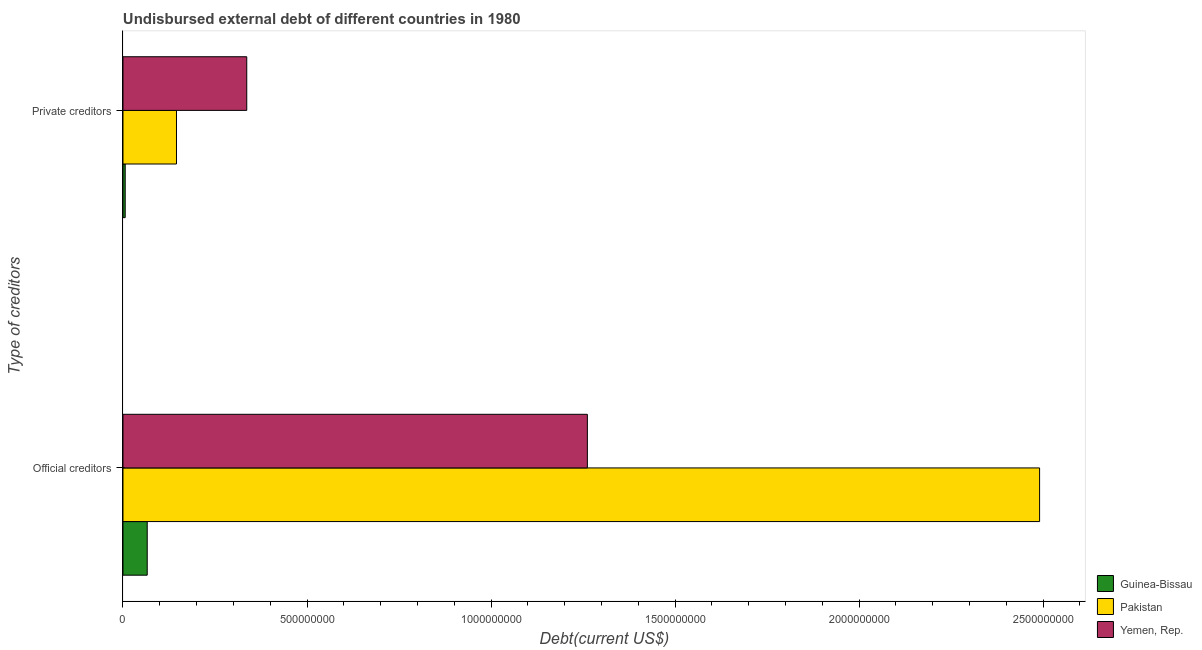How many groups of bars are there?
Provide a short and direct response. 2. Are the number of bars per tick equal to the number of legend labels?
Offer a very short reply. Yes. How many bars are there on the 1st tick from the bottom?
Provide a succinct answer. 3. What is the label of the 2nd group of bars from the top?
Your answer should be compact. Official creditors. What is the undisbursed external debt of private creditors in Yemen, Rep.?
Give a very brief answer. 3.36e+08. Across all countries, what is the maximum undisbursed external debt of private creditors?
Ensure brevity in your answer.  3.36e+08. Across all countries, what is the minimum undisbursed external debt of private creditors?
Your answer should be compact. 6.04e+06. In which country was the undisbursed external debt of private creditors maximum?
Make the answer very short. Yemen, Rep. In which country was the undisbursed external debt of official creditors minimum?
Your answer should be compact. Guinea-Bissau. What is the total undisbursed external debt of private creditors in the graph?
Offer a terse response. 4.88e+08. What is the difference between the undisbursed external debt of official creditors in Guinea-Bissau and that in Yemen, Rep.?
Keep it short and to the point. -1.20e+09. What is the difference between the undisbursed external debt of private creditors in Guinea-Bissau and the undisbursed external debt of official creditors in Pakistan?
Provide a short and direct response. -2.48e+09. What is the average undisbursed external debt of official creditors per country?
Ensure brevity in your answer.  1.27e+09. What is the difference between the undisbursed external debt of official creditors and undisbursed external debt of private creditors in Yemen, Rep.?
Your answer should be very brief. 9.25e+08. In how many countries, is the undisbursed external debt of private creditors greater than 200000000 US$?
Make the answer very short. 1. What is the ratio of the undisbursed external debt of official creditors in Guinea-Bissau to that in Pakistan?
Your response must be concise. 0.03. What does the 1st bar from the bottom in Private creditors represents?
Your response must be concise. Guinea-Bissau. How many bars are there?
Offer a very short reply. 6. Are all the bars in the graph horizontal?
Your answer should be compact. Yes. How many legend labels are there?
Provide a short and direct response. 3. How are the legend labels stacked?
Your answer should be very brief. Vertical. What is the title of the graph?
Offer a very short reply. Undisbursed external debt of different countries in 1980. What is the label or title of the X-axis?
Give a very brief answer. Debt(current US$). What is the label or title of the Y-axis?
Provide a succinct answer. Type of creditors. What is the Debt(current US$) in Guinea-Bissau in Official creditors?
Ensure brevity in your answer.  6.59e+07. What is the Debt(current US$) in Pakistan in Official creditors?
Your answer should be very brief. 2.49e+09. What is the Debt(current US$) in Yemen, Rep. in Official creditors?
Make the answer very short. 1.26e+09. What is the Debt(current US$) in Guinea-Bissau in Private creditors?
Your answer should be compact. 6.04e+06. What is the Debt(current US$) of Pakistan in Private creditors?
Provide a succinct answer. 1.45e+08. What is the Debt(current US$) of Yemen, Rep. in Private creditors?
Provide a short and direct response. 3.36e+08. Across all Type of creditors, what is the maximum Debt(current US$) in Guinea-Bissau?
Your answer should be very brief. 6.59e+07. Across all Type of creditors, what is the maximum Debt(current US$) in Pakistan?
Your answer should be very brief. 2.49e+09. Across all Type of creditors, what is the maximum Debt(current US$) in Yemen, Rep.?
Your answer should be compact. 1.26e+09. Across all Type of creditors, what is the minimum Debt(current US$) of Guinea-Bissau?
Offer a very short reply. 6.04e+06. Across all Type of creditors, what is the minimum Debt(current US$) in Pakistan?
Your response must be concise. 1.45e+08. Across all Type of creditors, what is the minimum Debt(current US$) of Yemen, Rep.?
Ensure brevity in your answer.  3.36e+08. What is the total Debt(current US$) in Guinea-Bissau in the graph?
Offer a terse response. 7.19e+07. What is the total Debt(current US$) in Pakistan in the graph?
Ensure brevity in your answer.  2.64e+09. What is the total Debt(current US$) in Yemen, Rep. in the graph?
Keep it short and to the point. 1.60e+09. What is the difference between the Debt(current US$) in Guinea-Bissau in Official creditors and that in Private creditors?
Your answer should be very brief. 5.98e+07. What is the difference between the Debt(current US$) in Pakistan in Official creditors and that in Private creditors?
Your response must be concise. 2.35e+09. What is the difference between the Debt(current US$) in Yemen, Rep. in Official creditors and that in Private creditors?
Provide a succinct answer. 9.25e+08. What is the difference between the Debt(current US$) in Guinea-Bissau in Official creditors and the Debt(current US$) in Pakistan in Private creditors?
Offer a very short reply. -7.95e+07. What is the difference between the Debt(current US$) of Guinea-Bissau in Official creditors and the Debt(current US$) of Yemen, Rep. in Private creditors?
Make the answer very short. -2.70e+08. What is the difference between the Debt(current US$) of Pakistan in Official creditors and the Debt(current US$) of Yemen, Rep. in Private creditors?
Offer a very short reply. 2.15e+09. What is the average Debt(current US$) of Guinea-Bissau per Type of creditors?
Offer a very short reply. 3.60e+07. What is the average Debt(current US$) of Pakistan per Type of creditors?
Provide a succinct answer. 1.32e+09. What is the average Debt(current US$) in Yemen, Rep. per Type of creditors?
Ensure brevity in your answer.  7.99e+08. What is the difference between the Debt(current US$) of Guinea-Bissau and Debt(current US$) of Pakistan in Official creditors?
Provide a succinct answer. -2.42e+09. What is the difference between the Debt(current US$) of Guinea-Bissau and Debt(current US$) of Yemen, Rep. in Official creditors?
Keep it short and to the point. -1.20e+09. What is the difference between the Debt(current US$) of Pakistan and Debt(current US$) of Yemen, Rep. in Official creditors?
Provide a short and direct response. 1.23e+09. What is the difference between the Debt(current US$) in Guinea-Bissau and Debt(current US$) in Pakistan in Private creditors?
Provide a short and direct response. -1.39e+08. What is the difference between the Debt(current US$) in Guinea-Bissau and Debt(current US$) in Yemen, Rep. in Private creditors?
Your answer should be very brief. -3.30e+08. What is the difference between the Debt(current US$) in Pakistan and Debt(current US$) in Yemen, Rep. in Private creditors?
Offer a terse response. -1.91e+08. What is the ratio of the Debt(current US$) of Guinea-Bissau in Official creditors to that in Private creditors?
Offer a terse response. 10.91. What is the ratio of the Debt(current US$) in Pakistan in Official creditors to that in Private creditors?
Provide a short and direct response. 17.13. What is the ratio of the Debt(current US$) of Yemen, Rep. in Official creditors to that in Private creditors?
Make the answer very short. 3.75. What is the difference between the highest and the second highest Debt(current US$) in Guinea-Bissau?
Provide a short and direct response. 5.98e+07. What is the difference between the highest and the second highest Debt(current US$) in Pakistan?
Keep it short and to the point. 2.35e+09. What is the difference between the highest and the second highest Debt(current US$) of Yemen, Rep.?
Make the answer very short. 9.25e+08. What is the difference between the highest and the lowest Debt(current US$) of Guinea-Bissau?
Offer a very short reply. 5.98e+07. What is the difference between the highest and the lowest Debt(current US$) in Pakistan?
Offer a terse response. 2.35e+09. What is the difference between the highest and the lowest Debt(current US$) in Yemen, Rep.?
Offer a terse response. 9.25e+08. 